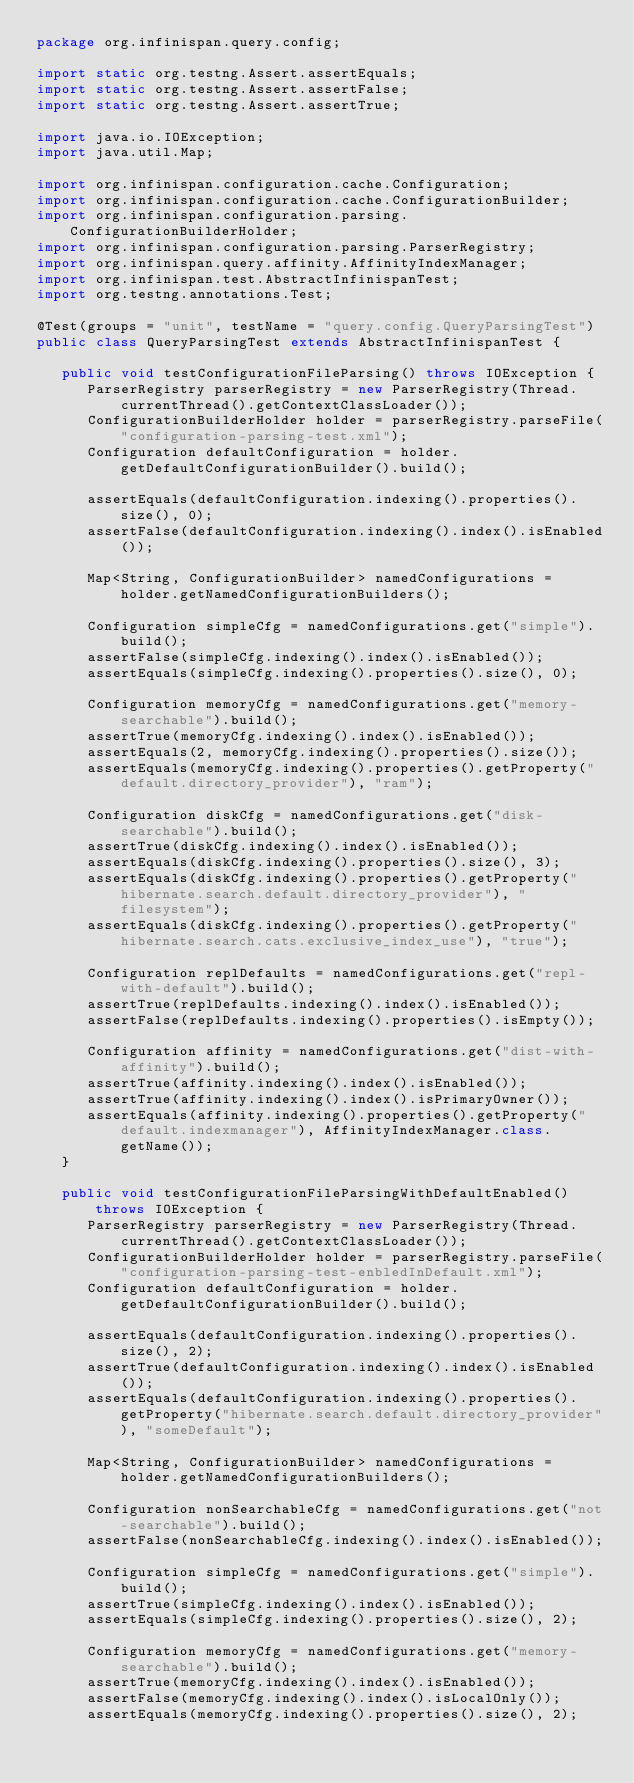Convert code to text. <code><loc_0><loc_0><loc_500><loc_500><_Java_>package org.infinispan.query.config;

import static org.testng.Assert.assertEquals;
import static org.testng.Assert.assertFalse;
import static org.testng.Assert.assertTrue;

import java.io.IOException;
import java.util.Map;

import org.infinispan.configuration.cache.Configuration;
import org.infinispan.configuration.cache.ConfigurationBuilder;
import org.infinispan.configuration.parsing.ConfigurationBuilderHolder;
import org.infinispan.configuration.parsing.ParserRegistry;
import org.infinispan.query.affinity.AffinityIndexManager;
import org.infinispan.test.AbstractInfinispanTest;
import org.testng.annotations.Test;

@Test(groups = "unit", testName = "query.config.QueryParsingTest")
public class QueryParsingTest extends AbstractInfinispanTest {

   public void testConfigurationFileParsing() throws IOException {
      ParserRegistry parserRegistry = new ParserRegistry(Thread.currentThread().getContextClassLoader());
      ConfigurationBuilderHolder holder = parserRegistry.parseFile("configuration-parsing-test.xml");
      Configuration defaultConfiguration = holder.getDefaultConfigurationBuilder().build();

      assertEquals(defaultConfiguration.indexing().properties().size(), 0);
      assertFalse(defaultConfiguration.indexing().index().isEnabled());

      Map<String, ConfigurationBuilder> namedConfigurations = holder.getNamedConfigurationBuilders();

      Configuration simpleCfg = namedConfigurations.get("simple").build();
      assertFalse(simpleCfg.indexing().index().isEnabled());
      assertEquals(simpleCfg.indexing().properties().size(), 0);

      Configuration memoryCfg = namedConfigurations.get("memory-searchable").build();
      assertTrue(memoryCfg.indexing().index().isEnabled());
      assertEquals(2, memoryCfg.indexing().properties().size());
      assertEquals(memoryCfg.indexing().properties().getProperty("default.directory_provider"), "ram");

      Configuration diskCfg = namedConfigurations.get("disk-searchable").build();
      assertTrue(diskCfg.indexing().index().isEnabled());
      assertEquals(diskCfg.indexing().properties().size(), 3);
      assertEquals(diskCfg.indexing().properties().getProperty("hibernate.search.default.directory_provider"), "filesystem");
      assertEquals(diskCfg.indexing().properties().getProperty("hibernate.search.cats.exclusive_index_use"), "true");

      Configuration replDefaults = namedConfigurations.get("repl-with-default").build();
      assertTrue(replDefaults.indexing().index().isEnabled());
      assertFalse(replDefaults.indexing().properties().isEmpty());

      Configuration affinity = namedConfigurations.get("dist-with-affinity").build();
      assertTrue(affinity.indexing().index().isEnabled());
      assertTrue(affinity.indexing().index().isPrimaryOwner());
      assertEquals(affinity.indexing().properties().getProperty("default.indexmanager"), AffinityIndexManager.class.getName());
   }

   public void testConfigurationFileParsingWithDefaultEnabled() throws IOException {
      ParserRegistry parserRegistry = new ParserRegistry(Thread.currentThread().getContextClassLoader());
      ConfigurationBuilderHolder holder = parserRegistry.parseFile("configuration-parsing-test-enbledInDefault.xml");
      Configuration defaultConfiguration = holder.getDefaultConfigurationBuilder().build();

      assertEquals(defaultConfiguration.indexing().properties().size(), 2);
      assertTrue(defaultConfiguration.indexing().index().isEnabled());
      assertEquals(defaultConfiguration.indexing().properties().getProperty("hibernate.search.default.directory_provider"), "someDefault");

      Map<String, ConfigurationBuilder> namedConfigurations = holder.getNamedConfigurationBuilders();

      Configuration nonSearchableCfg = namedConfigurations.get("not-searchable").build();
      assertFalse(nonSearchableCfg.indexing().index().isEnabled());

      Configuration simpleCfg = namedConfigurations.get("simple").build();
      assertTrue(simpleCfg.indexing().index().isEnabled());
      assertEquals(simpleCfg.indexing().properties().size(), 2);

      Configuration memoryCfg = namedConfigurations.get("memory-searchable").build();
      assertTrue(memoryCfg.indexing().index().isEnabled());
      assertFalse(memoryCfg.indexing().index().isLocalOnly());
      assertEquals(memoryCfg.indexing().properties().size(), 2);</code> 